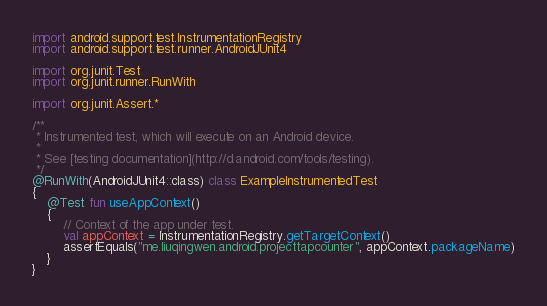<code> <loc_0><loc_0><loc_500><loc_500><_Kotlin_>import android.support.test.InstrumentationRegistry
import android.support.test.runner.AndroidJUnit4

import org.junit.Test
import org.junit.runner.RunWith

import org.junit.Assert.*

/**
 * Instrumented test, which will execute on an Android device.
 *
 * See [testing documentation](http://d.android.com/tools/testing).
 */
@RunWith(AndroidJUnit4::class) class ExampleInstrumentedTest
{
    @Test fun useAppContext()
    {
        // Context of the app under test.
        val appContext = InstrumentationRegistry.getTargetContext()
        assertEquals("me.liuqingwen.android.projecttapcounter", appContext.packageName)
    }
}
</code> 